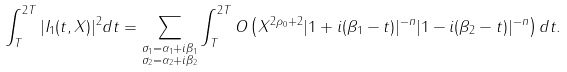<formula> <loc_0><loc_0><loc_500><loc_500>& \int _ { T } ^ { 2 T } | I _ { 1 } ( t , X ) | ^ { 2 } d t = \sum _ { \begin{subarray} { c } \sigma _ { 1 } = \alpha _ { 1 } + i \beta _ { 1 } \\ \sigma _ { 2 } = \alpha _ { 2 } + i \beta _ { 2 } \end{subarray} } \int _ { T } ^ { 2 T } O \left ( X ^ { 2 \rho _ { 0 } + 2 } | 1 + i ( \beta _ { 1 } - t ) | ^ { - n } | 1 - i ( \beta _ { 2 } - t ) | ^ { - n } \right ) d t .</formula> 